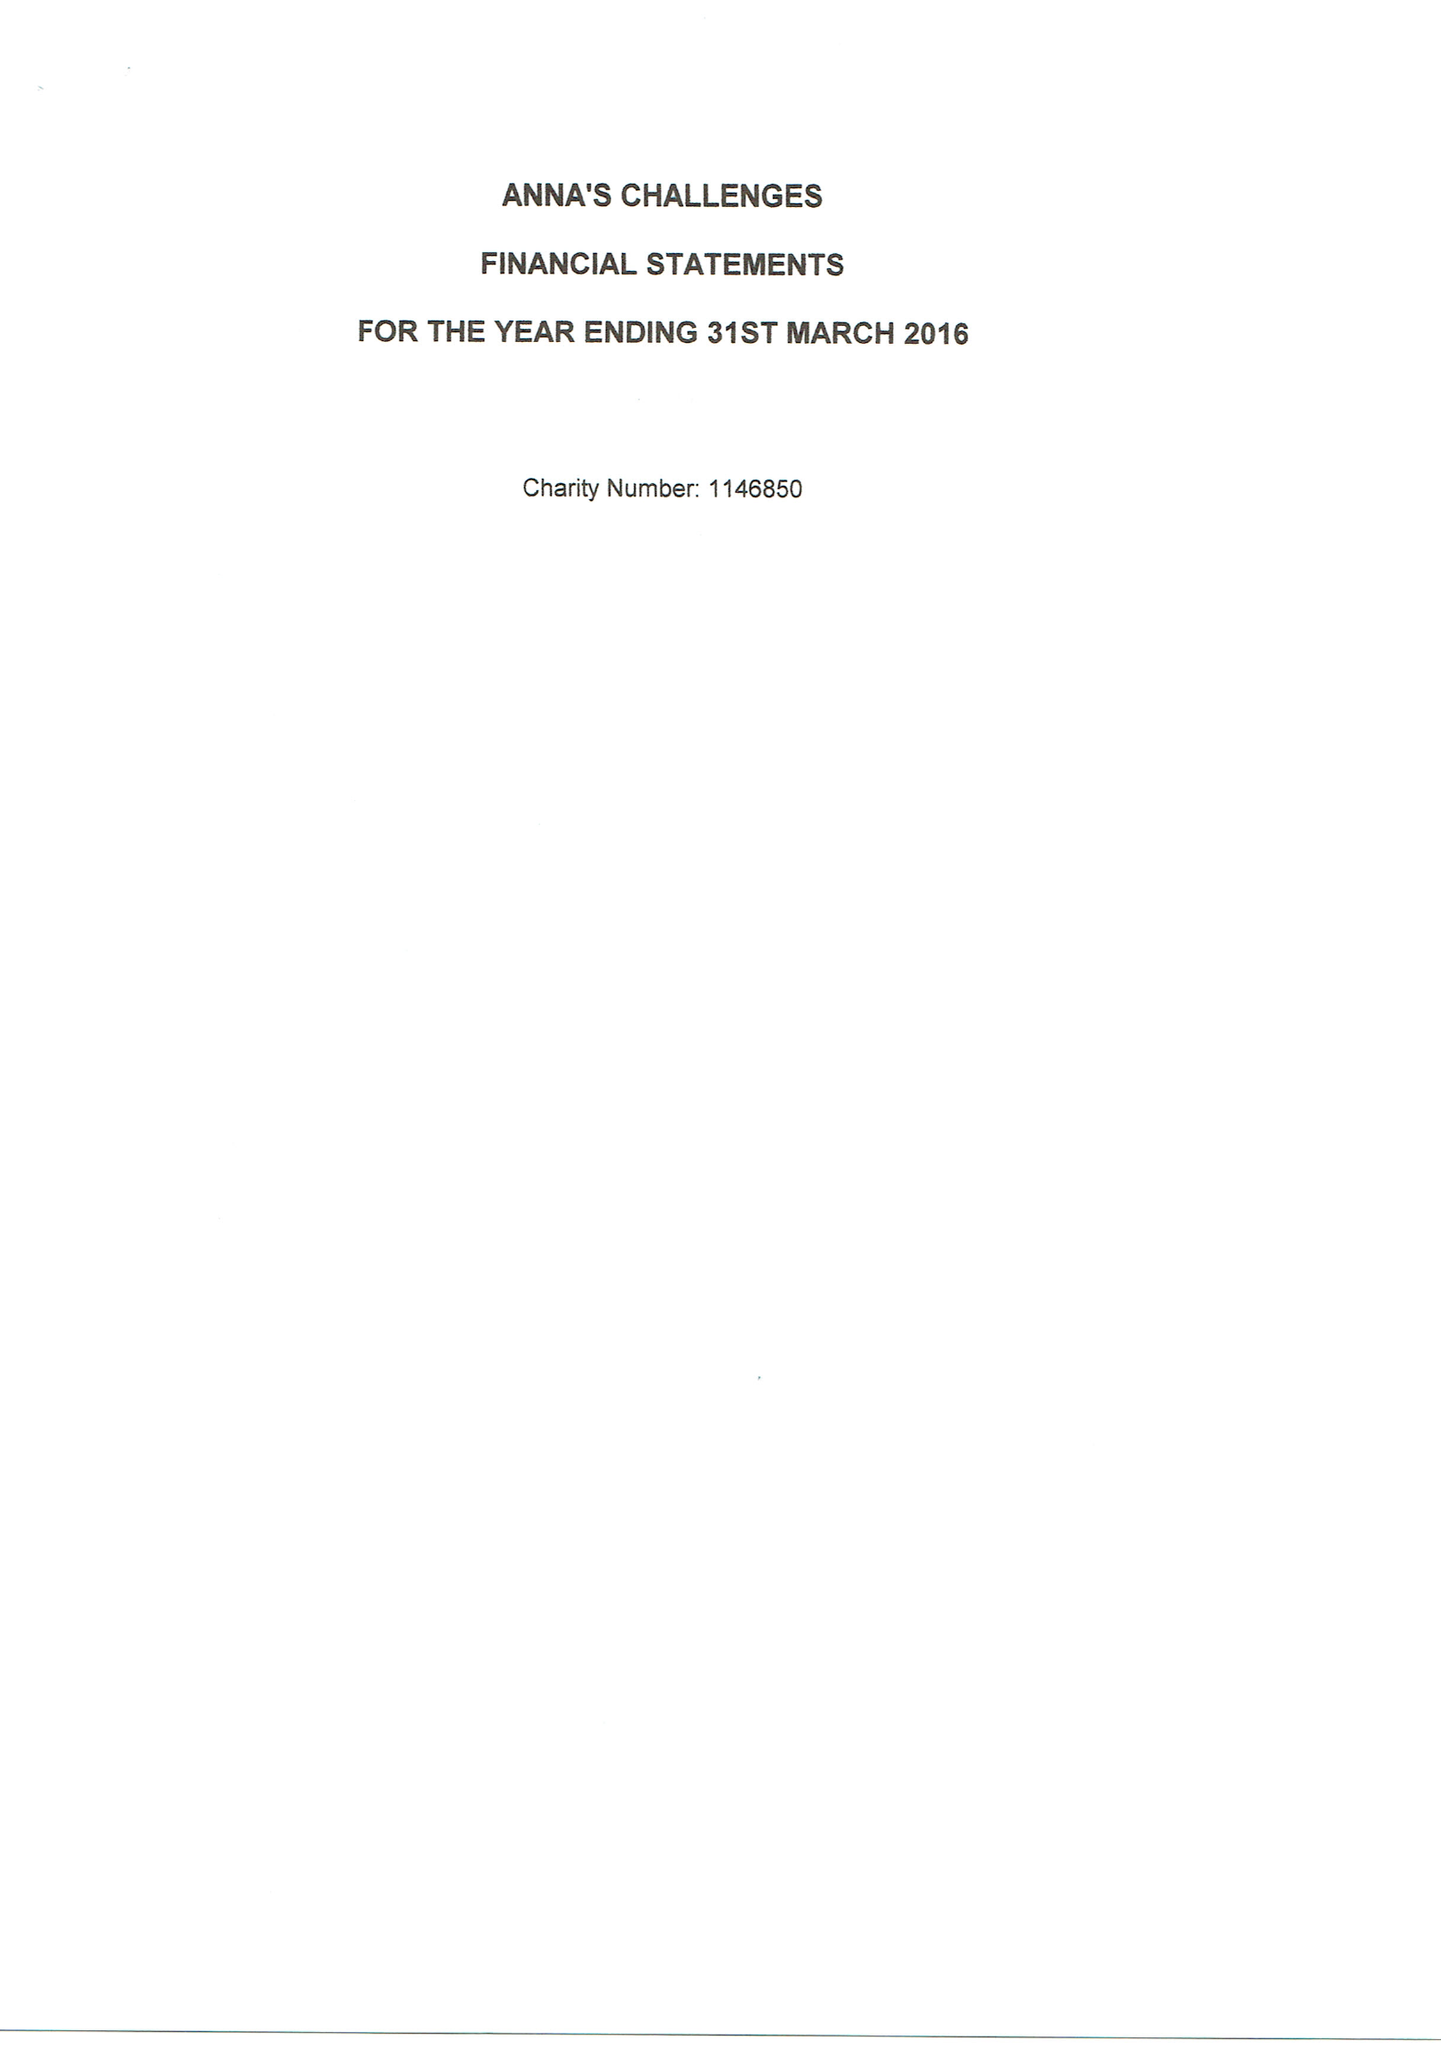What is the value for the address__postcode?
Answer the question using a single word or phrase. RG1 1AX 